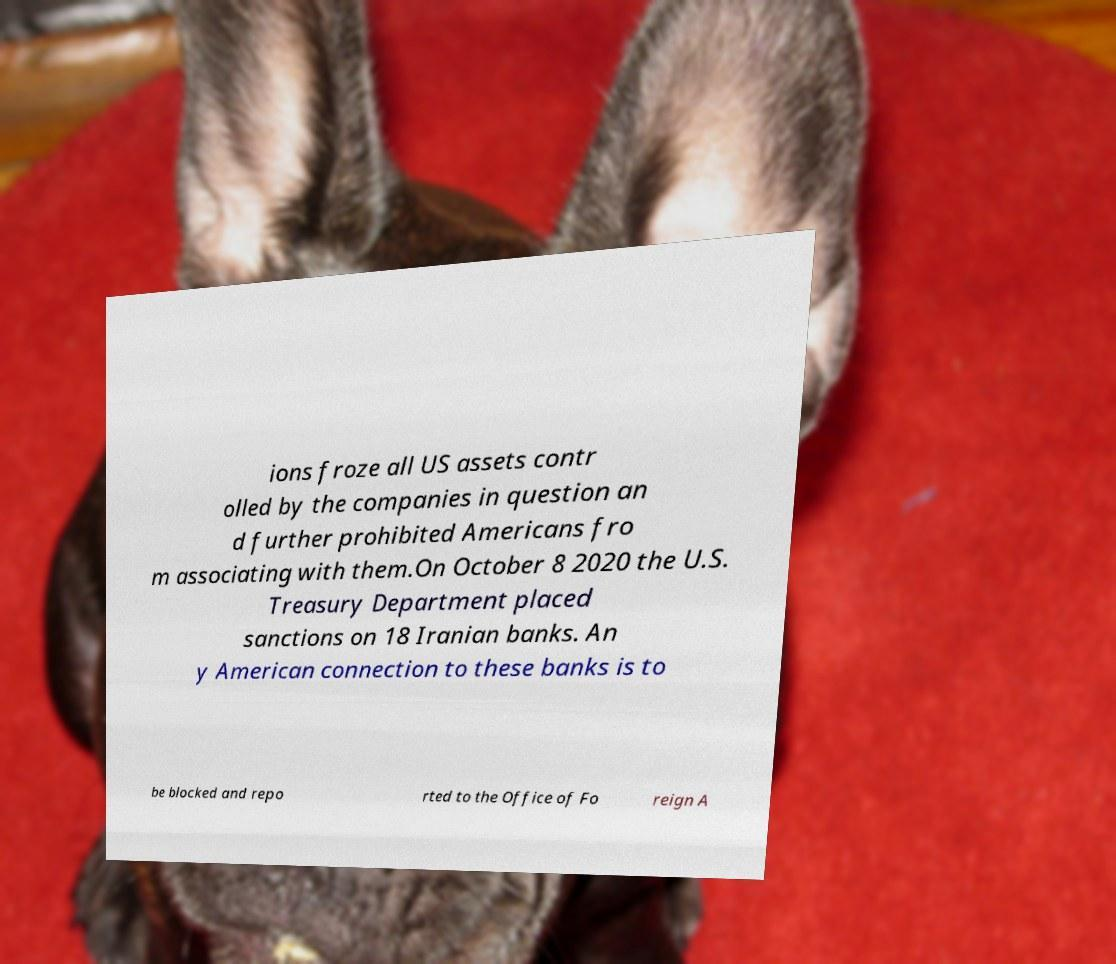Please identify and transcribe the text found in this image. ions froze all US assets contr olled by the companies in question an d further prohibited Americans fro m associating with them.On October 8 2020 the U.S. Treasury Department placed sanctions on 18 Iranian banks. An y American connection to these banks is to be blocked and repo rted to the Office of Fo reign A 